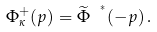Convert formula to latex. <formula><loc_0><loc_0><loc_500><loc_500>\Phi _ { \kappa } ^ { + } ( p ) = \widetilde { \Phi } \ ^ { ^ { * } } ( - p ) \, .</formula> 